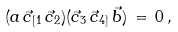<formula> <loc_0><loc_0><loc_500><loc_500>( a \, \vec { c } _ { [ 1 } \, \vec { c } _ { 2 } ) ( \vec { c } _ { 3 } \, \vec { c } _ { 4 ] } \, \vec { b } ) \, = \, 0 \, ,</formula> 